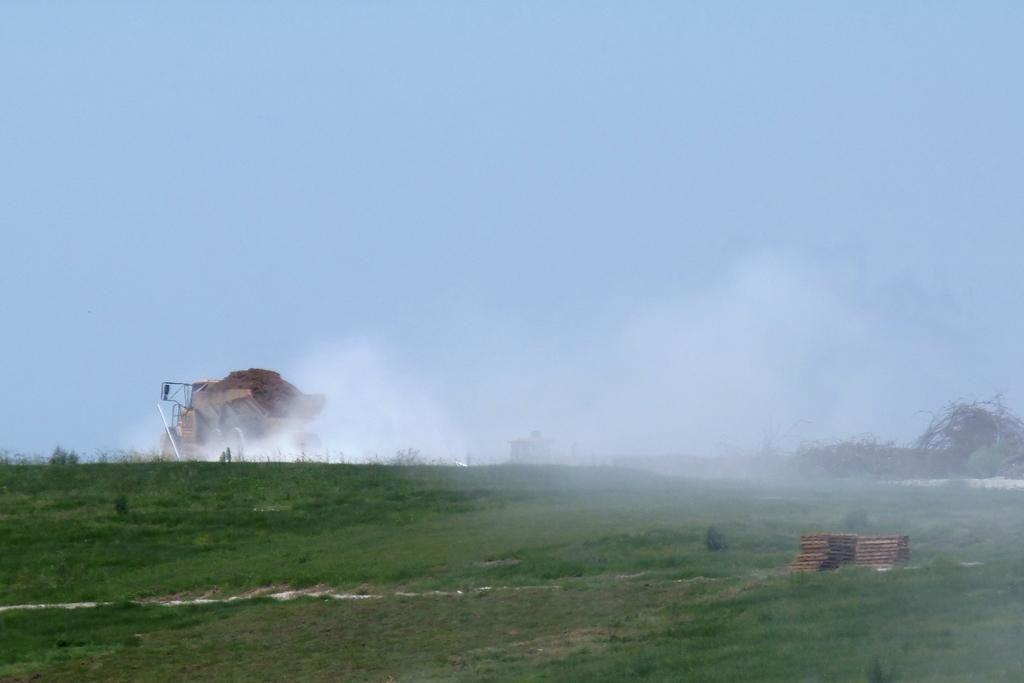What type of vegetation is present in the image? There is grass in the image. What else can be seen in the image besides the grass? There are objects in the image. What is visible in the background of the image? In the background, there is a vehicle, smoke, plants, and the sky. What type of hen is laying eggs in the image? There is no hen or eggs present in the image. How does the income of the person in the image affect the scene? There is no information about a person or their income in the image. 